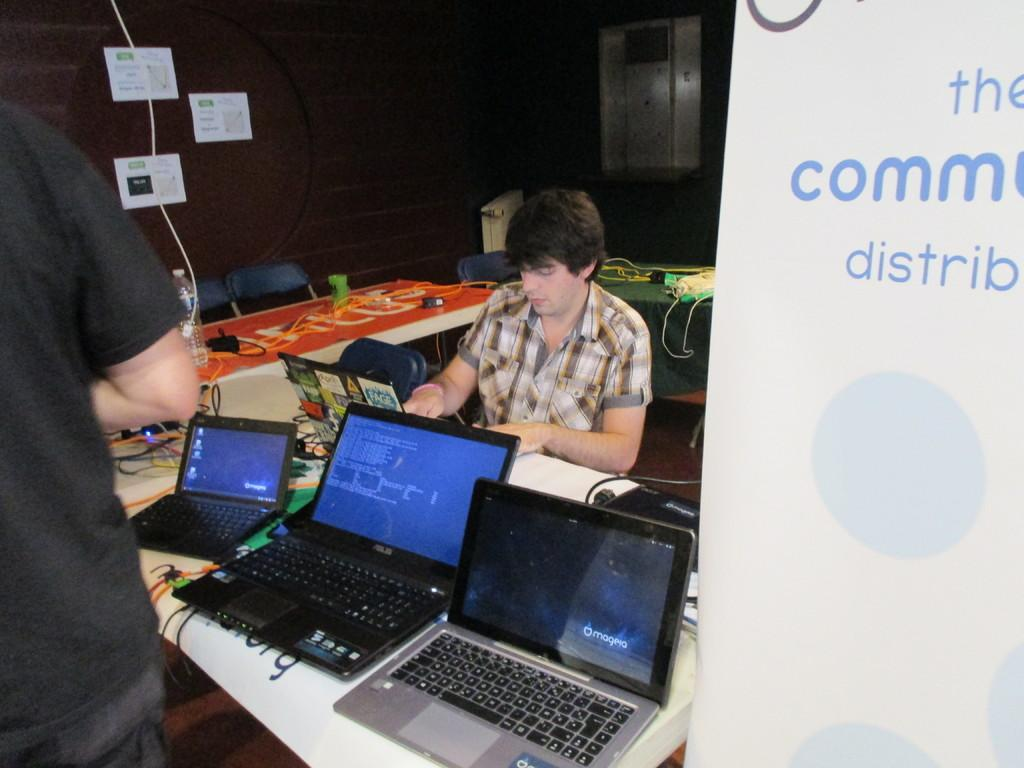<image>
Share a concise interpretation of the image provided. The back of a computer screen has a sticker on it with the word Fage. 